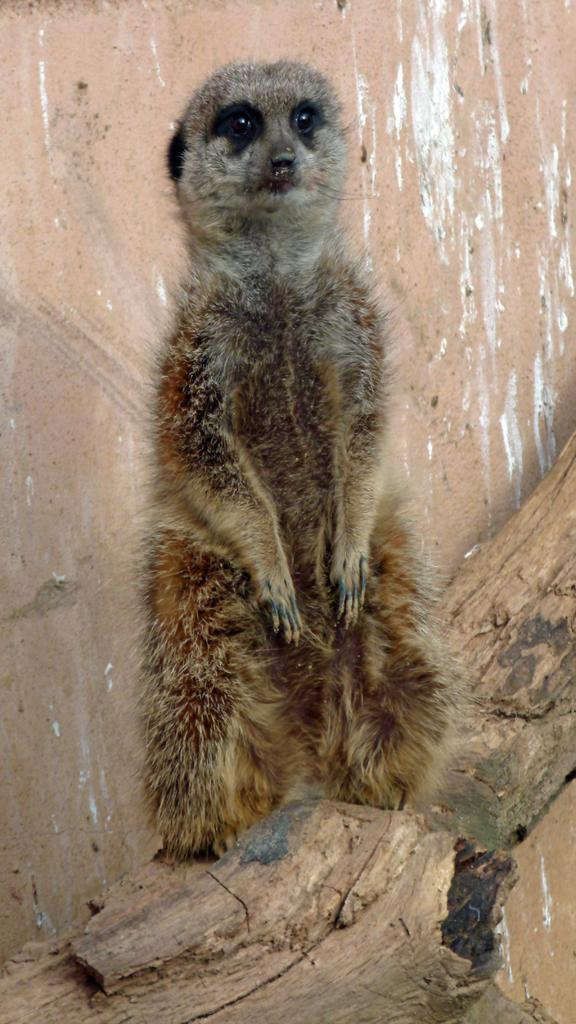What type of animal is in the image? There is an animal in the image, but its specific type is not mentioned in the facts. What color is the animal in the image? The animal is brown in color. What surface is the animal standing on? The animal is standing on wood. What color is the wall visible in the background of the image? There is a pink wall in the background of the image. Where was the image taken? The image was taken in a zoo. What type of skate is the animal using to move around in the image? There is no skate present in the image, and the animal is not moving. 